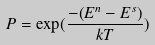<formula> <loc_0><loc_0><loc_500><loc_500>P = \exp ( \frac { - ( E ^ { n } - E ^ { s } ) } { k T } )</formula> 